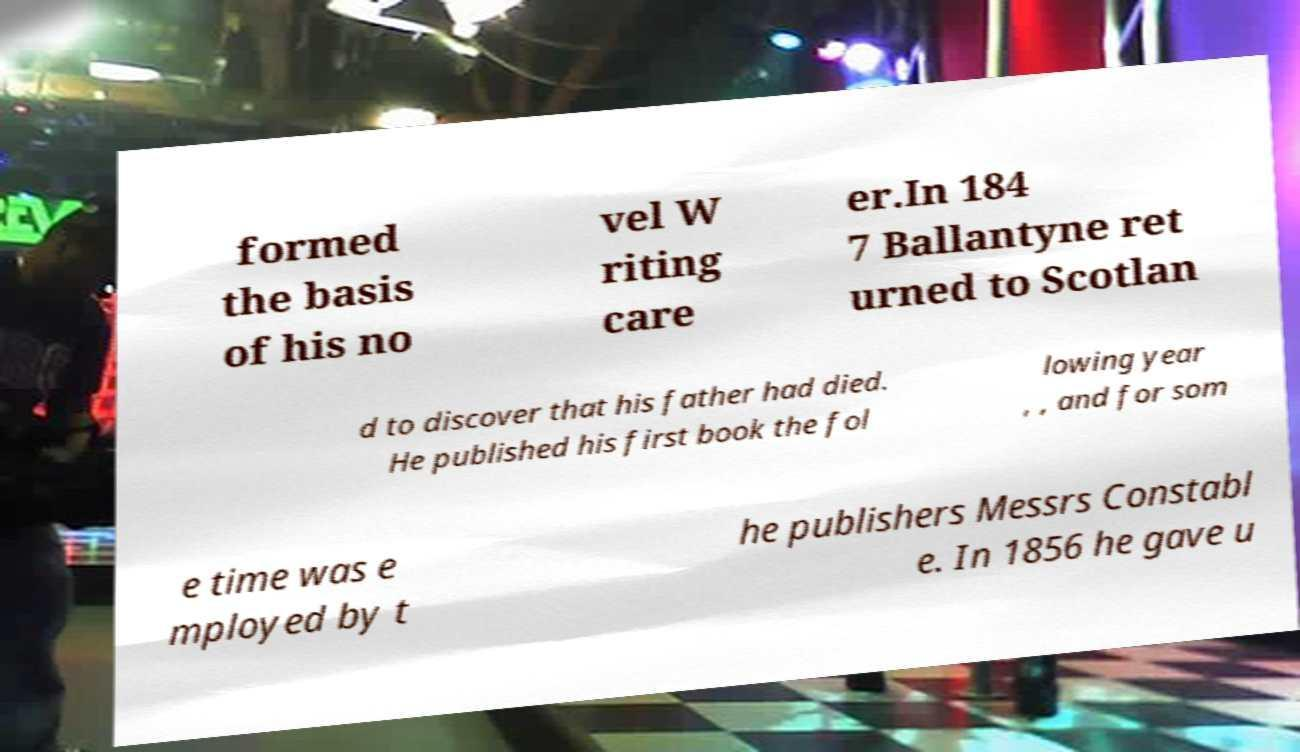Please identify and transcribe the text found in this image. formed the basis of his no vel W riting care er.In 184 7 Ballantyne ret urned to Scotlan d to discover that his father had died. He published his first book the fol lowing year , , and for som e time was e mployed by t he publishers Messrs Constabl e. In 1856 he gave u 